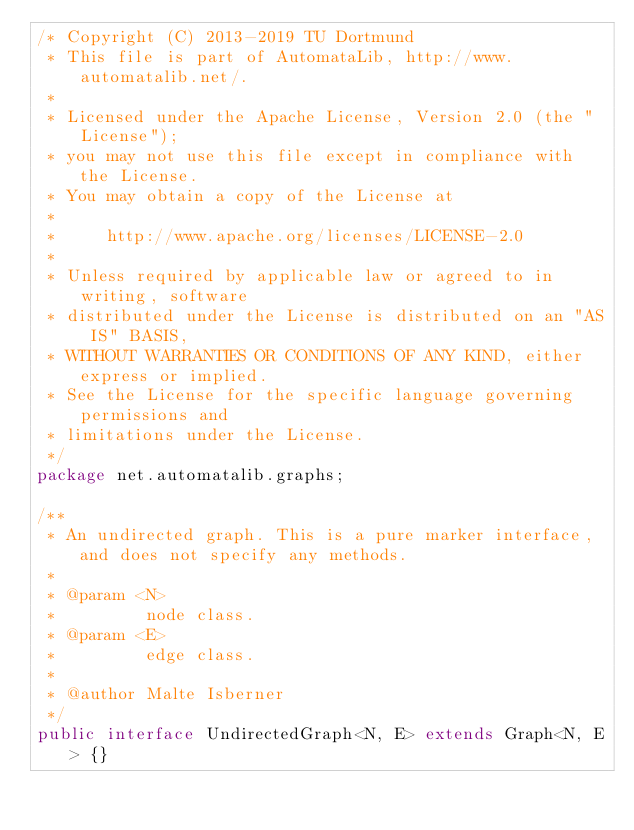<code> <loc_0><loc_0><loc_500><loc_500><_Java_>/* Copyright (C) 2013-2019 TU Dortmund
 * This file is part of AutomataLib, http://www.automatalib.net/.
 *
 * Licensed under the Apache License, Version 2.0 (the "License");
 * you may not use this file except in compliance with the License.
 * You may obtain a copy of the License at
 *
 *     http://www.apache.org/licenses/LICENSE-2.0
 *
 * Unless required by applicable law or agreed to in writing, software
 * distributed under the License is distributed on an "AS IS" BASIS,
 * WITHOUT WARRANTIES OR CONDITIONS OF ANY KIND, either express or implied.
 * See the License for the specific language governing permissions and
 * limitations under the License.
 */
package net.automatalib.graphs;

/**
 * An undirected graph. This is a pure marker interface, and does not specify any methods.
 *
 * @param <N>
 *         node class.
 * @param <E>
 *         edge class.
 *
 * @author Malte Isberner
 */
public interface UndirectedGraph<N, E> extends Graph<N, E> {}
</code> 